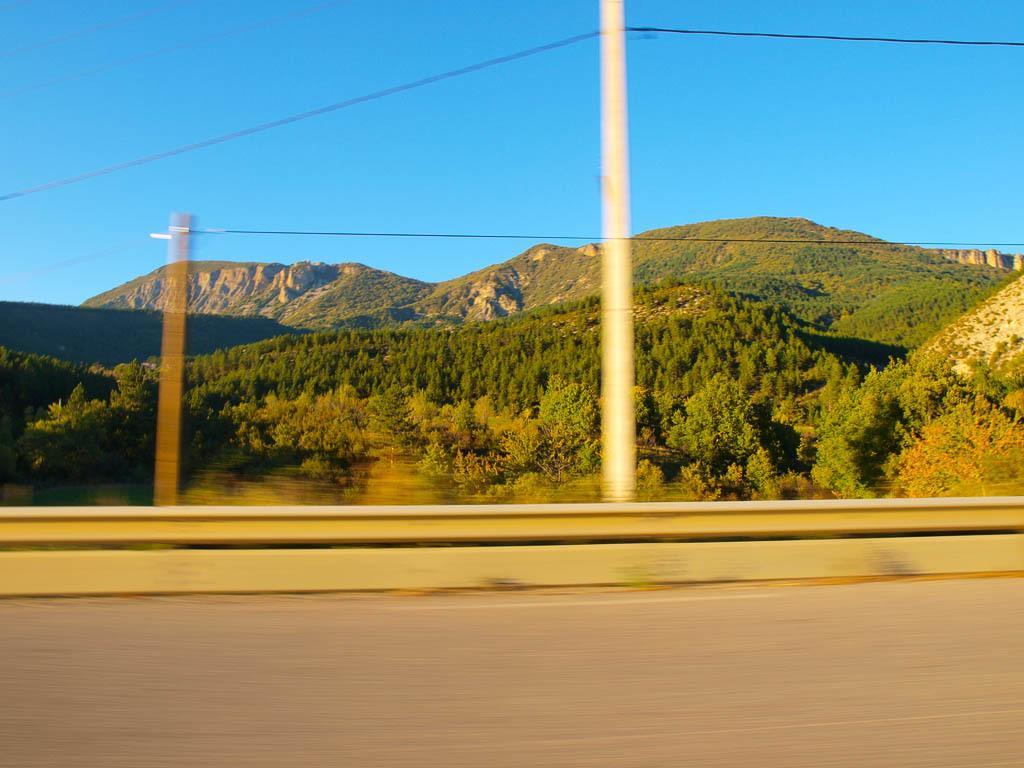Can you describe this image briefly? This picture shows a few trees and we see couple of poles and a blue sky. 